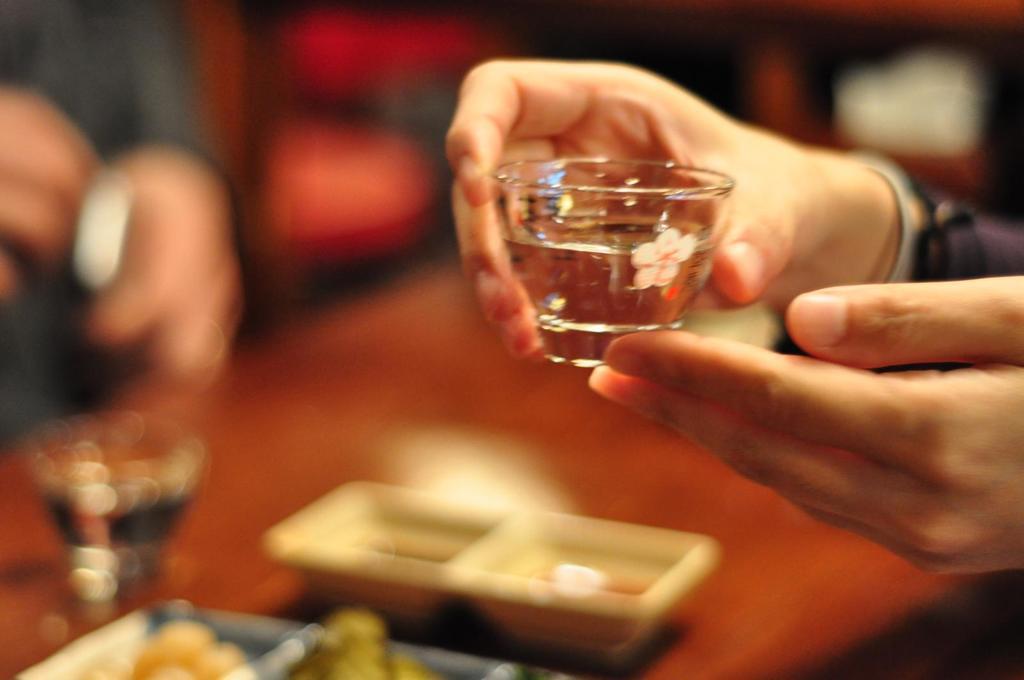How would you summarize this image in a sentence or two? In this image in the foreground there is one person who is holding a glass, and in the background there is a table. On the table there is glass and some bowls, and there is one person and the background is blurred. 